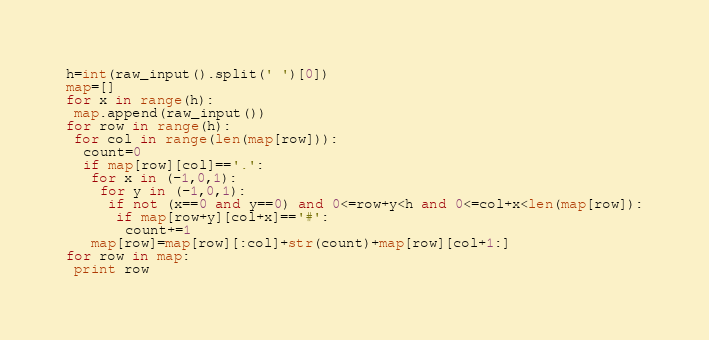Convert code to text. <code><loc_0><loc_0><loc_500><loc_500><_Python_>h=int(raw_input().split(' ')[0])
map=[]
for x in range(h):
 map.append(raw_input())
for row in range(h):
 for col in range(len(map[row])):
  count=0
  if map[row][col]=='.':
   for x in (-1,0,1):
    for y in (-1,0,1):
     if not (x==0 and y==0) and 0<=row+y<h and 0<=col+x<len(map[row]):
      if map[row+y][col+x]=='#':
       count+=1
   map[row]=map[row][:col]+str(count)+map[row][col+1:]
for row in map:
 print row</code> 